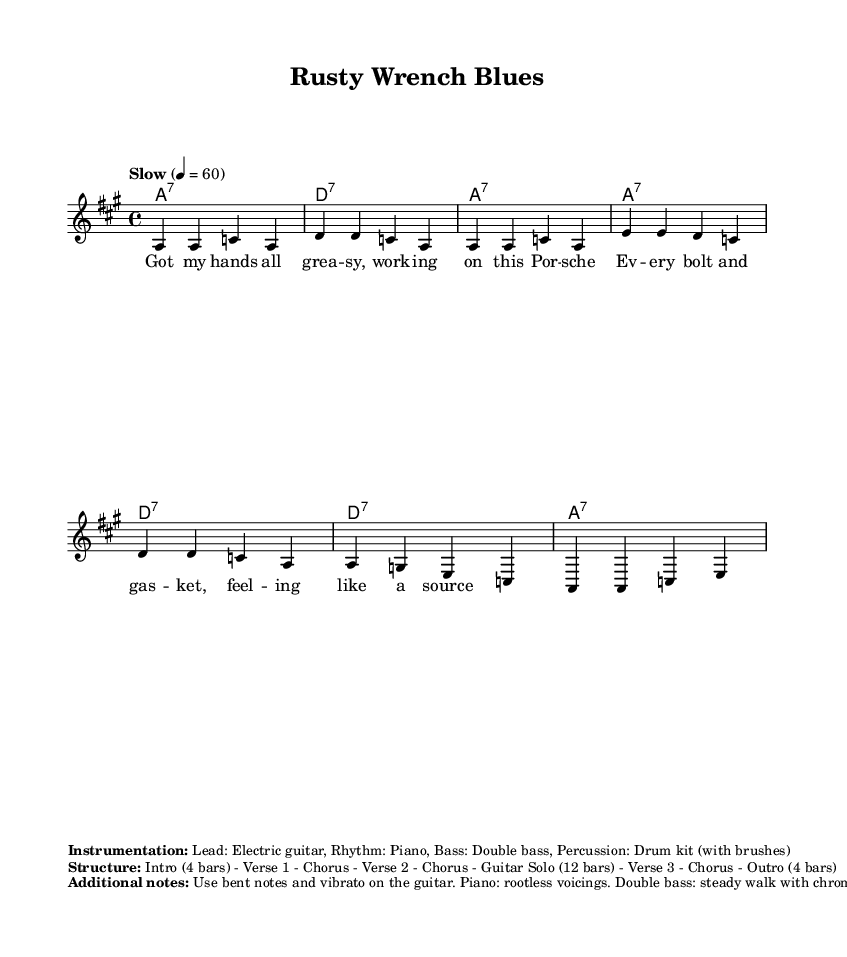What is the key signature of this music? The key signature is A major, indicated by three sharps (F#, C#, and G#), which can be confirmed at the beginning of the staff.
Answer: A major What is the time signature of this music? The time signature is 4/4, which is indicated at the beginning of the score next to the key signature. This means there are four beats in each measure.
Answer: 4/4 What is the tempo marking of this song? The tempo marking is "Slow," indicated in the score next to the tempo section, where it shows that the speed is set to a quarter note equal to 60 beats per minute.
Answer: Slow How many bars are in the melody section? Counting the melody notes and measures shown, there are eight measures in total. This is confirmed by the melody being broken down into groups of four notes in the score layout.
Answer: Eight What instruments are specified in the instrumentation? The instrumentation specifies Electric guitar, Piano, Double bass, and Drum kit (with brushes). This information is listed in the markup section near the score, summarizing the instruments involved.
Answer: Electric guitar, Piano, Double bass, Drum kit How many verses are included in the song structure? The song structure outlines three verses, as specified in the markup that includes "Verse 1," "Verse 2," and "Verse 3," indicating a clear count of verses in the arrangement.
Answer: Three What type of guitar techniques are suggested for this piece? The additional notes section suggests the use of bent notes and vibrato on the guitar, which is common in blues-style playing for expressing emotion. This can be found in the notes section targeting guitar techniques specifically.
Answer: Bent notes and vibrato 